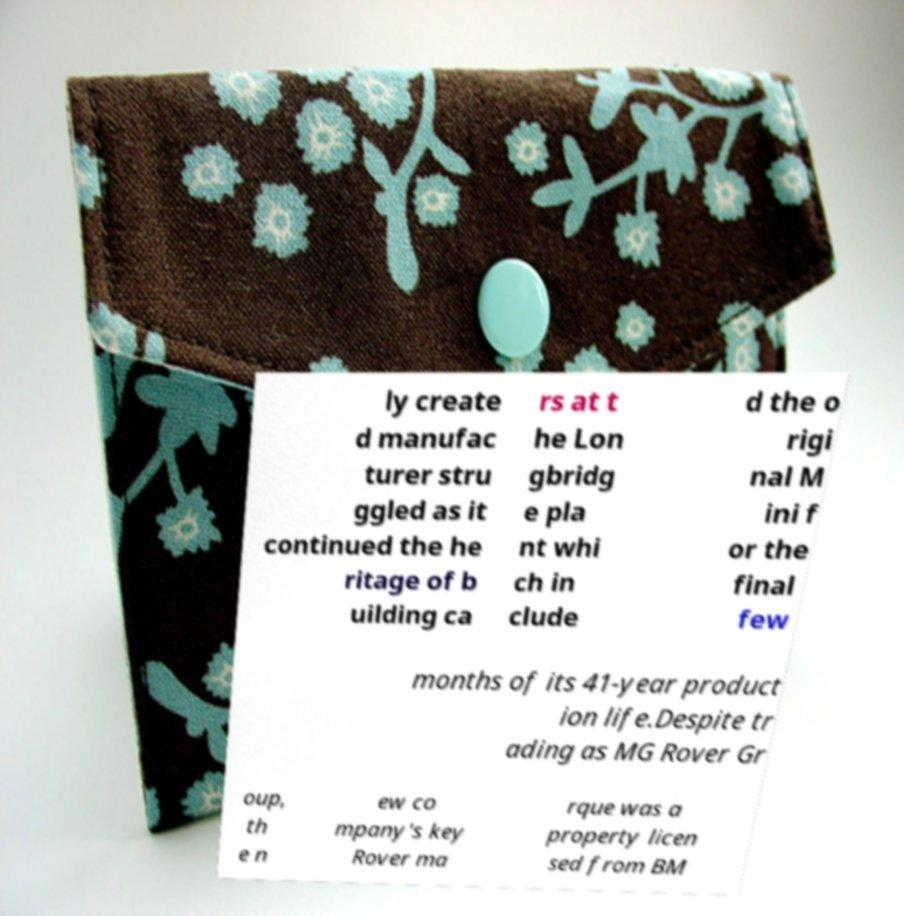I need the written content from this picture converted into text. Can you do that? ly create d manufac turer stru ggled as it continued the he ritage of b uilding ca rs at t he Lon gbridg e pla nt whi ch in clude d the o rigi nal M ini f or the final few months of its 41-year product ion life.Despite tr ading as MG Rover Gr oup, th e n ew co mpany's key Rover ma rque was a property licen sed from BM 